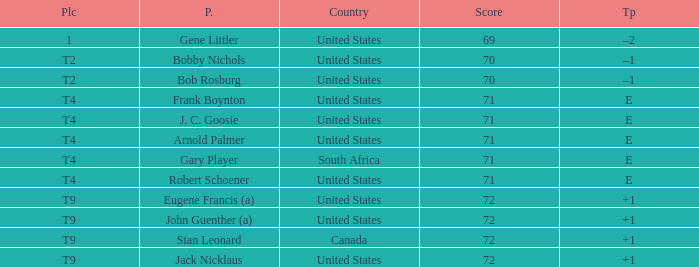Can you give me this table as a dict? {'header': ['Plc', 'P.', 'Country', 'Score', 'Tp'], 'rows': [['1', 'Gene Littler', 'United States', '69', '–2'], ['T2', 'Bobby Nichols', 'United States', '70', '–1'], ['T2', 'Bob Rosburg', 'United States', '70', '–1'], ['T4', 'Frank Boynton', 'United States', '71', 'E'], ['T4', 'J. C. Goosie', 'United States', '71', 'E'], ['T4', 'Arnold Palmer', 'United States', '71', 'E'], ['T4', 'Gary Player', 'South Africa', '71', 'E'], ['T4', 'Robert Schoener', 'United States', '71', 'E'], ['T9', 'Eugene Francis (a)', 'United States', '72', '+1'], ['T9', 'John Guenther (a)', 'United States', '72', '+1'], ['T9', 'Stan Leonard', 'Canada', '72', '+1'], ['T9', 'Jack Nicklaus', 'United States', '72', '+1']]} What is Place, when Score is less than 70? 1.0. 